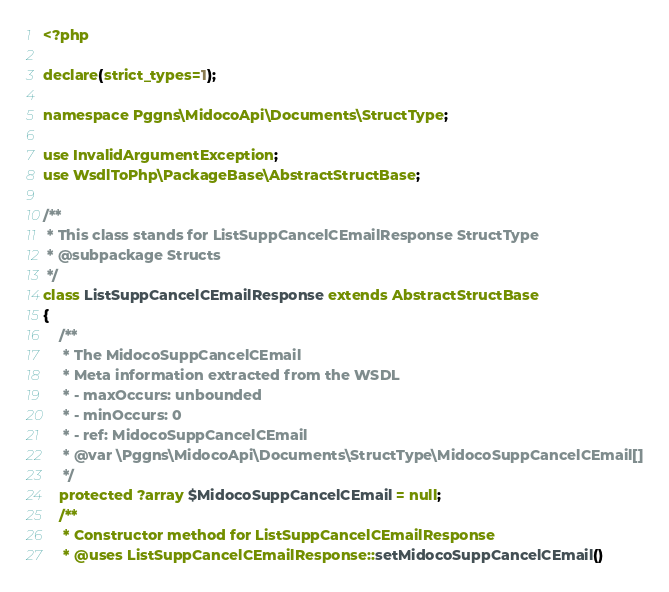Convert code to text. <code><loc_0><loc_0><loc_500><loc_500><_PHP_><?php

declare(strict_types=1);

namespace Pggns\MidocoApi\Documents\StructType;

use InvalidArgumentException;
use WsdlToPhp\PackageBase\AbstractStructBase;

/**
 * This class stands for ListSuppCancelCEmailResponse StructType
 * @subpackage Structs
 */
class ListSuppCancelCEmailResponse extends AbstractStructBase
{
    /**
     * The MidocoSuppCancelCEmail
     * Meta information extracted from the WSDL
     * - maxOccurs: unbounded
     * - minOccurs: 0
     * - ref: MidocoSuppCancelCEmail
     * @var \Pggns\MidocoApi\Documents\StructType\MidocoSuppCancelCEmail[]
     */
    protected ?array $MidocoSuppCancelCEmail = null;
    /**
     * Constructor method for ListSuppCancelCEmailResponse
     * @uses ListSuppCancelCEmailResponse::setMidocoSuppCancelCEmail()</code> 